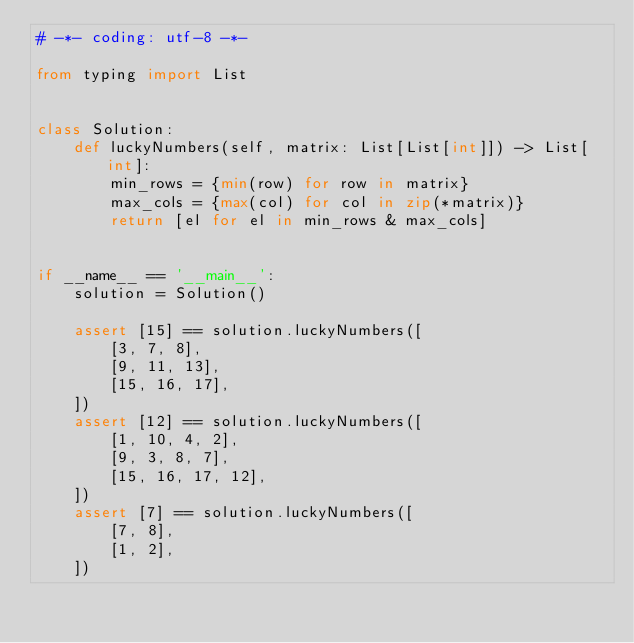<code> <loc_0><loc_0><loc_500><loc_500><_Python_># -*- coding: utf-8 -*-

from typing import List


class Solution:
    def luckyNumbers(self, matrix: List[List[int]]) -> List[int]:
        min_rows = {min(row) for row in matrix}
        max_cols = {max(col) for col in zip(*matrix)}
        return [el for el in min_rows & max_cols]


if __name__ == '__main__':
    solution = Solution()

    assert [15] == solution.luckyNumbers([
        [3, 7, 8],
        [9, 11, 13],
        [15, 16, 17],
    ])
    assert [12] == solution.luckyNumbers([
        [1, 10, 4, 2],
        [9, 3, 8, 7],
        [15, 16, 17, 12],
    ])
    assert [7] == solution.luckyNumbers([
        [7, 8],
        [1, 2],
    ])
</code> 